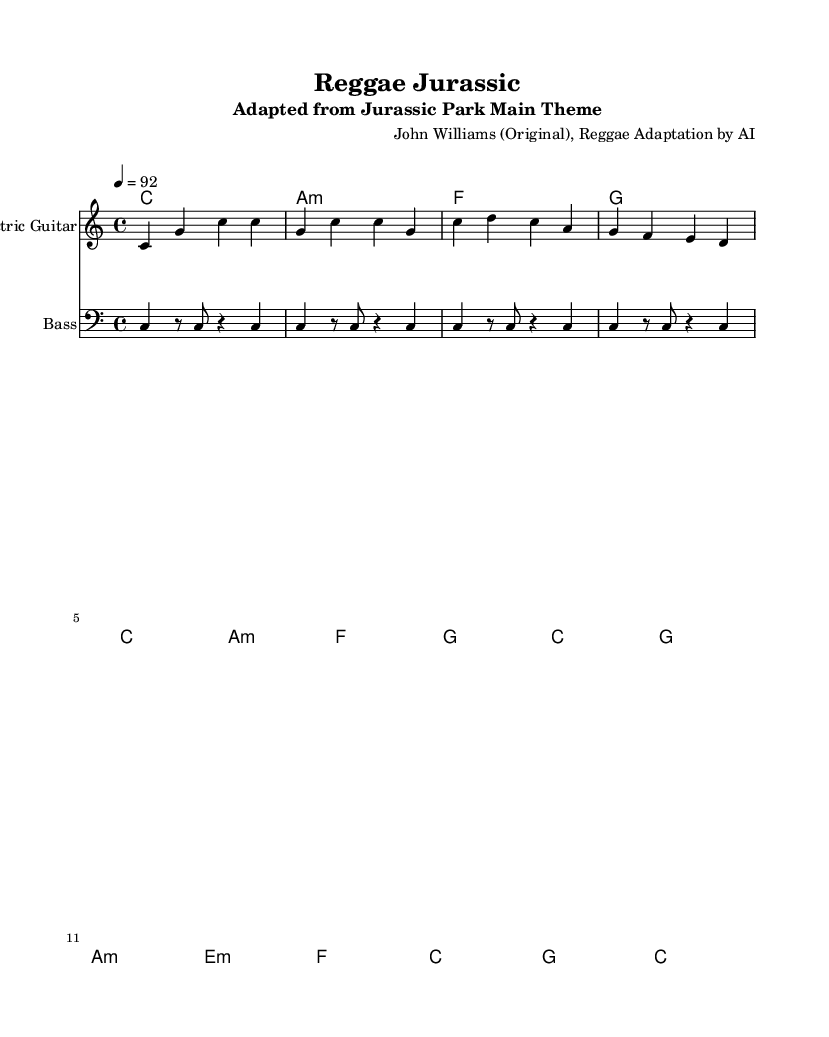What is the key signature of this music? The key signature is C major, which has no sharps or flats.
Answer: C major What is the time signature of this piece? The time signature is indicated at the beginning of the score as 4/4, which means there are four beats per measure.
Answer: 4/4 What is the tempo marking for this piece? The tempo marking is indicated as quarter note = 92, meaning the tempo is set to 92 beats per minute.
Answer: 92 How many measures are in the electric guitar part? The electric guitar part consists of 8 measures, as it spans 8 sets of bars in the staff.
Answer: 8 Which chord comes after the C major chord in the chord progression? The second chord after C major is A minor, which is denoted in the chord symbols under the staff.
Answer: A minor How does the reggae adaptation maintain a different feel compared to the original theme? The reggae adaptation typically utilizes a relaxed rhythm and syncopation, creating a laid-back groove distinct from the original orchestral style.
Answer: Relaxed rhythm What is the role of the bass guitar in this reggae cover? The bass guitar provides rhythmic foundation and supports the harmonic structure, playing the root notes of the chords indicated beneath the staff.
Answer: Root notes 